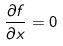<formula> <loc_0><loc_0><loc_500><loc_500>\frac { \partial f } { \partial x } = 0</formula> 